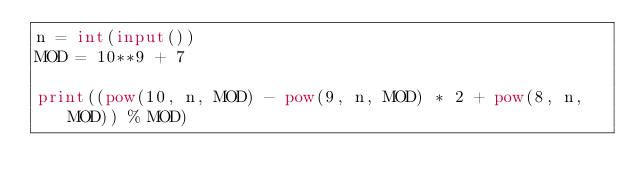Convert code to text. <code><loc_0><loc_0><loc_500><loc_500><_Python_>n = int(input())
MOD = 10**9 + 7

print((pow(10, n, MOD) - pow(9, n, MOD) * 2 + pow(8, n, MOD)) % MOD)</code> 